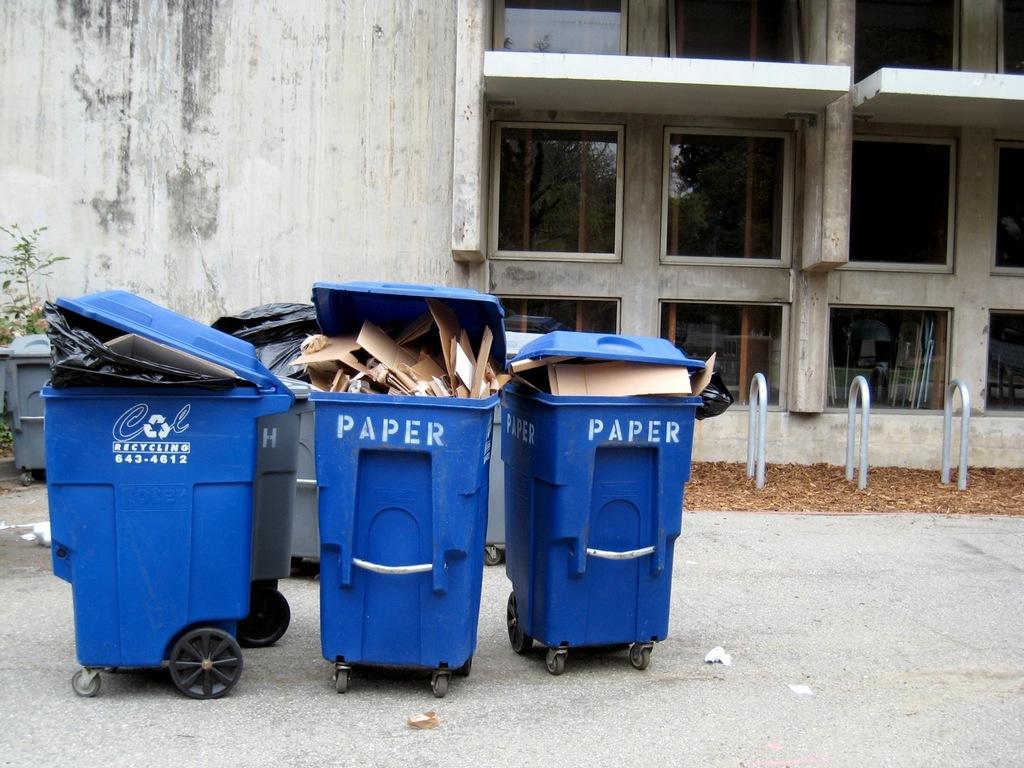Are these for paper?
Offer a terse response. Yes. What is the phone number on the far left blue bin?
Provide a succinct answer. 643-4612. 